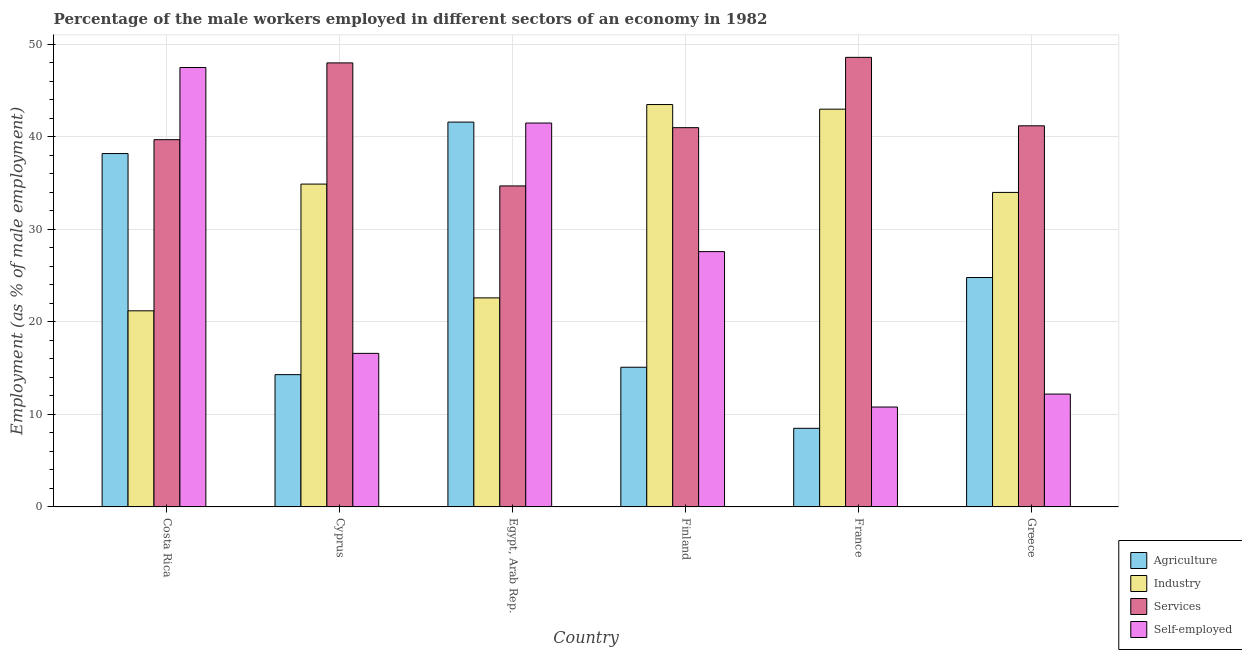How many different coloured bars are there?
Offer a terse response. 4. How many groups of bars are there?
Keep it short and to the point. 6. Are the number of bars per tick equal to the number of legend labels?
Make the answer very short. Yes. How many bars are there on the 2nd tick from the left?
Give a very brief answer. 4. What is the label of the 5th group of bars from the left?
Offer a very short reply. France. In how many cases, is the number of bars for a given country not equal to the number of legend labels?
Provide a short and direct response. 0. What is the percentage of male workers in services in France?
Offer a terse response. 48.6. Across all countries, what is the maximum percentage of male workers in agriculture?
Offer a very short reply. 41.6. Across all countries, what is the minimum percentage of male workers in services?
Your answer should be compact. 34.7. In which country was the percentage of male workers in services minimum?
Provide a short and direct response. Egypt, Arab Rep. What is the total percentage of male workers in agriculture in the graph?
Your response must be concise. 142.5. What is the difference between the percentage of self employed male workers in Greece and the percentage of male workers in services in France?
Make the answer very short. -36.4. What is the average percentage of male workers in services per country?
Make the answer very short. 42.2. What is the difference between the percentage of male workers in agriculture and percentage of male workers in industry in Egypt, Arab Rep.?
Ensure brevity in your answer.  19. In how many countries, is the percentage of self employed male workers greater than 48 %?
Ensure brevity in your answer.  0. What is the ratio of the percentage of male workers in services in Costa Rica to that in Egypt, Arab Rep.?
Make the answer very short. 1.14. Is the percentage of self employed male workers in France less than that in Greece?
Your answer should be compact. Yes. What is the difference between the highest and the lowest percentage of male workers in industry?
Offer a very short reply. 22.3. In how many countries, is the percentage of male workers in industry greater than the average percentage of male workers in industry taken over all countries?
Offer a terse response. 4. What does the 2nd bar from the left in Costa Rica represents?
Offer a terse response. Industry. What does the 4th bar from the right in Costa Rica represents?
Your answer should be very brief. Agriculture. Is it the case that in every country, the sum of the percentage of male workers in agriculture and percentage of male workers in industry is greater than the percentage of male workers in services?
Make the answer very short. Yes. How many countries are there in the graph?
Your response must be concise. 6. Does the graph contain grids?
Offer a very short reply. Yes. Where does the legend appear in the graph?
Ensure brevity in your answer.  Bottom right. How are the legend labels stacked?
Your answer should be very brief. Vertical. What is the title of the graph?
Give a very brief answer. Percentage of the male workers employed in different sectors of an economy in 1982. Does "Payroll services" appear as one of the legend labels in the graph?
Your answer should be compact. No. What is the label or title of the Y-axis?
Your answer should be very brief. Employment (as % of male employment). What is the Employment (as % of male employment) of Agriculture in Costa Rica?
Provide a short and direct response. 38.2. What is the Employment (as % of male employment) in Industry in Costa Rica?
Your answer should be compact. 21.2. What is the Employment (as % of male employment) in Services in Costa Rica?
Make the answer very short. 39.7. What is the Employment (as % of male employment) of Self-employed in Costa Rica?
Your answer should be compact. 47.5. What is the Employment (as % of male employment) of Agriculture in Cyprus?
Make the answer very short. 14.3. What is the Employment (as % of male employment) in Industry in Cyprus?
Offer a terse response. 34.9. What is the Employment (as % of male employment) of Services in Cyprus?
Ensure brevity in your answer.  48. What is the Employment (as % of male employment) of Self-employed in Cyprus?
Your answer should be compact. 16.6. What is the Employment (as % of male employment) in Agriculture in Egypt, Arab Rep.?
Ensure brevity in your answer.  41.6. What is the Employment (as % of male employment) in Industry in Egypt, Arab Rep.?
Offer a very short reply. 22.6. What is the Employment (as % of male employment) of Services in Egypt, Arab Rep.?
Give a very brief answer. 34.7. What is the Employment (as % of male employment) in Self-employed in Egypt, Arab Rep.?
Offer a terse response. 41.5. What is the Employment (as % of male employment) of Agriculture in Finland?
Give a very brief answer. 15.1. What is the Employment (as % of male employment) of Industry in Finland?
Give a very brief answer. 43.5. What is the Employment (as % of male employment) in Services in Finland?
Give a very brief answer. 41. What is the Employment (as % of male employment) in Self-employed in Finland?
Give a very brief answer. 27.6. What is the Employment (as % of male employment) in Agriculture in France?
Give a very brief answer. 8.5. What is the Employment (as % of male employment) in Services in France?
Your response must be concise. 48.6. What is the Employment (as % of male employment) of Self-employed in France?
Give a very brief answer. 10.8. What is the Employment (as % of male employment) in Agriculture in Greece?
Make the answer very short. 24.8. What is the Employment (as % of male employment) in Industry in Greece?
Offer a very short reply. 34. What is the Employment (as % of male employment) in Services in Greece?
Offer a terse response. 41.2. What is the Employment (as % of male employment) of Self-employed in Greece?
Your answer should be compact. 12.2. Across all countries, what is the maximum Employment (as % of male employment) of Agriculture?
Your answer should be very brief. 41.6. Across all countries, what is the maximum Employment (as % of male employment) of Industry?
Your response must be concise. 43.5. Across all countries, what is the maximum Employment (as % of male employment) of Services?
Your answer should be compact. 48.6. Across all countries, what is the maximum Employment (as % of male employment) in Self-employed?
Offer a terse response. 47.5. Across all countries, what is the minimum Employment (as % of male employment) in Industry?
Offer a terse response. 21.2. Across all countries, what is the minimum Employment (as % of male employment) of Services?
Your answer should be very brief. 34.7. Across all countries, what is the minimum Employment (as % of male employment) of Self-employed?
Your response must be concise. 10.8. What is the total Employment (as % of male employment) of Agriculture in the graph?
Make the answer very short. 142.5. What is the total Employment (as % of male employment) in Industry in the graph?
Your answer should be very brief. 199.2. What is the total Employment (as % of male employment) of Services in the graph?
Ensure brevity in your answer.  253.2. What is the total Employment (as % of male employment) in Self-employed in the graph?
Keep it short and to the point. 156.2. What is the difference between the Employment (as % of male employment) in Agriculture in Costa Rica and that in Cyprus?
Provide a short and direct response. 23.9. What is the difference between the Employment (as % of male employment) in Industry in Costa Rica and that in Cyprus?
Keep it short and to the point. -13.7. What is the difference between the Employment (as % of male employment) of Services in Costa Rica and that in Cyprus?
Your response must be concise. -8.3. What is the difference between the Employment (as % of male employment) in Self-employed in Costa Rica and that in Cyprus?
Provide a short and direct response. 30.9. What is the difference between the Employment (as % of male employment) in Services in Costa Rica and that in Egypt, Arab Rep.?
Your response must be concise. 5. What is the difference between the Employment (as % of male employment) in Self-employed in Costa Rica and that in Egypt, Arab Rep.?
Your response must be concise. 6. What is the difference between the Employment (as % of male employment) of Agriculture in Costa Rica and that in Finland?
Your answer should be compact. 23.1. What is the difference between the Employment (as % of male employment) of Industry in Costa Rica and that in Finland?
Offer a terse response. -22.3. What is the difference between the Employment (as % of male employment) of Agriculture in Costa Rica and that in France?
Your response must be concise. 29.7. What is the difference between the Employment (as % of male employment) in Industry in Costa Rica and that in France?
Give a very brief answer. -21.8. What is the difference between the Employment (as % of male employment) of Services in Costa Rica and that in France?
Ensure brevity in your answer.  -8.9. What is the difference between the Employment (as % of male employment) of Self-employed in Costa Rica and that in France?
Make the answer very short. 36.7. What is the difference between the Employment (as % of male employment) in Agriculture in Costa Rica and that in Greece?
Provide a succinct answer. 13.4. What is the difference between the Employment (as % of male employment) of Services in Costa Rica and that in Greece?
Provide a short and direct response. -1.5. What is the difference between the Employment (as % of male employment) of Self-employed in Costa Rica and that in Greece?
Offer a terse response. 35.3. What is the difference between the Employment (as % of male employment) in Agriculture in Cyprus and that in Egypt, Arab Rep.?
Provide a succinct answer. -27.3. What is the difference between the Employment (as % of male employment) of Industry in Cyprus and that in Egypt, Arab Rep.?
Ensure brevity in your answer.  12.3. What is the difference between the Employment (as % of male employment) of Self-employed in Cyprus and that in Egypt, Arab Rep.?
Your answer should be compact. -24.9. What is the difference between the Employment (as % of male employment) in Agriculture in Cyprus and that in Finland?
Your answer should be compact. -0.8. What is the difference between the Employment (as % of male employment) of Industry in Cyprus and that in Finland?
Your response must be concise. -8.6. What is the difference between the Employment (as % of male employment) of Services in Cyprus and that in Finland?
Keep it short and to the point. 7. What is the difference between the Employment (as % of male employment) of Agriculture in Cyprus and that in France?
Offer a terse response. 5.8. What is the difference between the Employment (as % of male employment) in Industry in Cyprus and that in France?
Offer a very short reply. -8.1. What is the difference between the Employment (as % of male employment) of Industry in Egypt, Arab Rep. and that in Finland?
Your answer should be very brief. -20.9. What is the difference between the Employment (as % of male employment) in Services in Egypt, Arab Rep. and that in Finland?
Make the answer very short. -6.3. What is the difference between the Employment (as % of male employment) in Self-employed in Egypt, Arab Rep. and that in Finland?
Your answer should be very brief. 13.9. What is the difference between the Employment (as % of male employment) of Agriculture in Egypt, Arab Rep. and that in France?
Your answer should be very brief. 33.1. What is the difference between the Employment (as % of male employment) of Industry in Egypt, Arab Rep. and that in France?
Your response must be concise. -20.4. What is the difference between the Employment (as % of male employment) in Services in Egypt, Arab Rep. and that in France?
Your response must be concise. -13.9. What is the difference between the Employment (as % of male employment) in Self-employed in Egypt, Arab Rep. and that in France?
Your answer should be compact. 30.7. What is the difference between the Employment (as % of male employment) in Agriculture in Egypt, Arab Rep. and that in Greece?
Provide a succinct answer. 16.8. What is the difference between the Employment (as % of male employment) of Industry in Egypt, Arab Rep. and that in Greece?
Ensure brevity in your answer.  -11.4. What is the difference between the Employment (as % of male employment) of Services in Egypt, Arab Rep. and that in Greece?
Your response must be concise. -6.5. What is the difference between the Employment (as % of male employment) of Self-employed in Egypt, Arab Rep. and that in Greece?
Your response must be concise. 29.3. What is the difference between the Employment (as % of male employment) of Agriculture in Finland and that in France?
Offer a terse response. 6.6. What is the difference between the Employment (as % of male employment) of Services in Finland and that in France?
Offer a very short reply. -7.6. What is the difference between the Employment (as % of male employment) in Self-employed in Finland and that in France?
Offer a very short reply. 16.8. What is the difference between the Employment (as % of male employment) in Services in Finland and that in Greece?
Keep it short and to the point. -0.2. What is the difference between the Employment (as % of male employment) of Agriculture in France and that in Greece?
Give a very brief answer. -16.3. What is the difference between the Employment (as % of male employment) of Services in France and that in Greece?
Offer a terse response. 7.4. What is the difference between the Employment (as % of male employment) of Self-employed in France and that in Greece?
Ensure brevity in your answer.  -1.4. What is the difference between the Employment (as % of male employment) of Agriculture in Costa Rica and the Employment (as % of male employment) of Self-employed in Cyprus?
Your answer should be compact. 21.6. What is the difference between the Employment (as % of male employment) of Industry in Costa Rica and the Employment (as % of male employment) of Services in Cyprus?
Provide a short and direct response. -26.8. What is the difference between the Employment (as % of male employment) of Industry in Costa Rica and the Employment (as % of male employment) of Self-employed in Cyprus?
Provide a succinct answer. 4.6. What is the difference between the Employment (as % of male employment) of Services in Costa Rica and the Employment (as % of male employment) of Self-employed in Cyprus?
Provide a short and direct response. 23.1. What is the difference between the Employment (as % of male employment) in Agriculture in Costa Rica and the Employment (as % of male employment) in Industry in Egypt, Arab Rep.?
Your response must be concise. 15.6. What is the difference between the Employment (as % of male employment) of Agriculture in Costa Rica and the Employment (as % of male employment) of Services in Egypt, Arab Rep.?
Make the answer very short. 3.5. What is the difference between the Employment (as % of male employment) of Industry in Costa Rica and the Employment (as % of male employment) of Services in Egypt, Arab Rep.?
Provide a short and direct response. -13.5. What is the difference between the Employment (as % of male employment) in Industry in Costa Rica and the Employment (as % of male employment) in Self-employed in Egypt, Arab Rep.?
Your response must be concise. -20.3. What is the difference between the Employment (as % of male employment) in Services in Costa Rica and the Employment (as % of male employment) in Self-employed in Egypt, Arab Rep.?
Offer a very short reply. -1.8. What is the difference between the Employment (as % of male employment) in Agriculture in Costa Rica and the Employment (as % of male employment) in Self-employed in Finland?
Offer a terse response. 10.6. What is the difference between the Employment (as % of male employment) of Industry in Costa Rica and the Employment (as % of male employment) of Services in Finland?
Give a very brief answer. -19.8. What is the difference between the Employment (as % of male employment) in Industry in Costa Rica and the Employment (as % of male employment) in Self-employed in Finland?
Your answer should be compact. -6.4. What is the difference between the Employment (as % of male employment) of Services in Costa Rica and the Employment (as % of male employment) of Self-employed in Finland?
Your response must be concise. 12.1. What is the difference between the Employment (as % of male employment) in Agriculture in Costa Rica and the Employment (as % of male employment) in Industry in France?
Make the answer very short. -4.8. What is the difference between the Employment (as % of male employment) in Agriculture in Costa Rica and the Employment (as % of male employment) in Self-employed in France?
Provide a succinct answer. 27.4. What is the difference between the Employment (as % of male employment) of Industry in Costa Rica and the Employment (as % of male employment) of Services in France?
Provide a succinct answer. -27.4. What is the difference between the Employment (as % of male employment) of Industry in Costa Rica and the Employment (as % of male employment) of Self-employed in France?
Offer a terse response. 10.4. What is the difference between the Employment (as % of male employment) in Services in Costa Rica and the Employment (as % of male employment) in Self-employed in France?
Ensure brevity in your answer.  28.9. What is the difference between the Employment (as % of male employment) of Agriculture in Costa Rica and the Employment (as % of male employment) of Industry in Greece?
Provide a succinct answer. 4.2. What is the difference between the Employment (as % of male employment) in Agriculture in Costa Rica and the Employment (as % of male employment) in Self-employed in Greece?
Keep it short and to the point. 26. What is the difference between the Employment (as % of male employment) in Industry in Costa Rica and the Employment (as % of male employment) in Services in Greece?
Offer a terse response. -20. What is the difference between the Employment (as % of male employment) in Agriculture in Cyprus and the Employment (as % of male employment) in Services in Egypt, Arab Rep.?
Offer a terse response. -20.4. What is the difference between the Employment (as % of male employment) in Agriculture in Cyprus and the Employment (as % of male employment) in Self-employed in Egypt, Arab Rep.?
Ensure brevity in your answer.  -27.2. What is the difference between the Employment (as % of male employment) of Industry in Cyprus and the Employment (as % of male employment) of Services in Egypt, Arab Rep.?
Offer a terse response. 0.2. What is the difference between the Employment (as % of male employment) in Industry in Cyprus and the Employment (as % of male employment) in Self-employed in Egypt, Arab Rep.?
Provide a short and direct response. -6.6. What is the difference between the Employment (as % of male employment) in Services in Cyprus and the Employment (as % of male employment) in Self-employed in Egypt, Arab Rep.?
Provide a succinct answer. 6.5. What is the difference between the Employment (as % of male employment) of Agriculture in Cyprus and the Employment (as % of male employment) of Industry in Finland?
Offer a very short reply. -29.2. What is the difference between the Employment (as % of male employment) in Agriculture in Cyprus and the Employment (as % of male employment) in Services in Finland?
Ensure brevity in your answer.  -26.7. What is the difference between the Employment (as % of male employment) in Services in Cyprus and the Employment (as % of male employment) in Self-employed in Finland?
Your answer should be very brief. 20.4. What is the difference between the Employment (as % of male employment) of Agriculture in Cyprus and the Employment (as % of male employment) of Industry in France?
Make the answer very short. -28.7. What is the difference between the Employment (as % of male employment) of Agriculture in Cyprus and the Employment (as % of male employment) of Services in France?
Provide a short and direct response. -34.3. What is the difference between the Employment (as % of male employment) in Agriculture in Cyprus and the Employment (as % of male employment) in Self-employed in France?
Offer a very short reply. 3.5. What is the difference between the Employment (as % of male employment) of Industry in Cyprus and the Employment (as % of male employment) of Services in France?
Your response must be concise. -13.7. What is the difference between the Employment (as % of male employment) of Industry in Cyprus and the Employment (as % of male employment) of Self-employed in France?
Keep it short and to the point. 24.1. What is the difference between the Employment (as % of male employment) of Services in Cyprus and the Employment (as % of male employment) of Self-employed in France?
Keep it short and to the point. 37.2. What is the difference between the Employment (as % of male employment) of Agriculture in Cyprus and the Employment (as % of male employment) of Industry in Greece?
Provide a short and direct response. -19.7. What is the difference between the Employment (as % of male employment) in Agriculture in Cyprus and the Employment (as % of male employment) in Services in Greece?
Provide a succinct answer. -26.9. What is the difference between the Employment (as % of male employment) of Industry in Cyprus and the Employment (as % of male employment) of Self-employed in Greece?
Provide a succinct answer. 22.7. What is the difference between the Employment (as % of male employment) in Services in Cyprus and the Employment (as % of male employment) in Self-employed in Greece?
Make the answer very short. 35.8. What is the difference between the Employment (as % of male employment) of Agriculture in Egypt, Arab Rep. and the Employment (as % of male employment) of Services in Finland?
Provide a succinct answer. 0.6. What is the difference between the Employment (as % of male employment) of Agriculture in Egypt, Arab Rep. and the Employment (as % of male employment) of Self-employed in Finland?
Keep it short and to the point. 14. What is the difference between the Employment (as % of male employment) in Industry in Egypt, Arab Rep. and the Employment (as % of male employment) in Services in Finland?
Your response must be concise. -18.4. What is the difference between the Employment (as % of male employment) of Agriculture in Egypt, Arab Rep. and the Employment (as % of male employment) of Services in France?
Provide a short and direct response. -7. What is the difference between the Employment (as % of male employment) in Agriculture in Egypt, Arab Rep. and the Employment (as % of male employment) in Self-employed in France?
Your response must be concise. 30.8. What is the difference between the Employment (as % of male employment) in Services in Egypt, Arab Rep. and the Employment (as % of male employment) in Self-employed in France?
Your response must be concise. 23.9. What is the difference between the Employment (as % of male employment) of Agriculture in Egypt, Arab Rep. and the Employment (as % of male employment) of Services in Greece?
Your answer should be very brief. 0.4. What is the difference between the Employment (as % of male employment) in Agriculture in Egypt, Arab Rep. and the Employment (as % of male employment) in Self-employed in Greece?
Ensure brevity in your answer.  29.4. What is the difference between the Employment (as % of male employment) of Industry in Egypt, Arab Rep. and the Employment (as % of male employment) of Services in Greece?
Make the answer very short. -18.6. What is the difference between the Employment (as % of male employment) in Industry in Egypt, Arab Rep. and the Employment (as % of male employment) in Self-employed in Greece?
Your response must be concise. 10.4. What is the difference between the Employment (as % of male employment) of Agriculture in Finland and the Employment (as % of male employment) of Industry in France?
Give a very brief answer. -27.9. What is the difference between the Employment (as % of male employment) of Agriculture in Finland and the Employment (as % of male employment) of Services in France?
Your answer should be compact. -33.5. What is the difference between the Employment (as % of male employment) of Industry in Finland and the Employment (as % of male employment) of Self-employed in France?
Keep it short and to the point. 32.7. What is the difference between the Employment (as % of male employment) in Services in Finland and the Employment (as % of male employment) in Self-employed in France?
Your answer should be very brief. 30.2. What is the difference between the Employment (as % of male employment) in Agriculture in Finland and the Employment (as % of male employment) in Industry in Greece?
Ensure brevity in your answer.  -18.9. What is the difference between the Employment (as % of male employment) in Agriculture in Finland and the Employment (as % of male employment) in Services in Greece?
Provide a short and direct response. -26.1. What is the difference between the Employment (as % of male employment) in Industry in Finland and the Employment (as % of male employment) in Self-employed in Greece?
Your response must be concise. 31.3. What is the difference between the Employment (as % of male employment) of Services in Finland and the Employment (as % of male employment) of Self-employed in Greece?
Your answer should be very brief. 28.8. What is the difference between the Employment (as % of male employment) in Agriculture in France and the Employment (as % of male employment) in Industry in Greece?
Your answer should be very brief. -25.5. What is the difference between the Employment (as % of male employment) of Agriculture in France and the Employment (as % of male employment) of Services in Greece?
Your answer should be compact. -32.7. What is the difference between the Employment (as % of male employment) in Agriculture in France and the Employment (as % of male employment) in Self-employed in Greece?
Provide a short and direct response. -3.7. What is the difference between the Employment (as % of male employment) in Industry in France and the Employment (as % of male employment) in Self-employed in Greece?
Offer a very short reply. 30.8. What is the difference between the Employment (as % of male employment) of Services in France and the Employment (as % of male employment) of Self-employed in Greece?
Your answer should be very brief. 36.4. What is the average Employment (as % of male employment) of Agriculture per country?
Provide a short and direct response. 23.75. What is the average Employment (as % of male employment) of Industry per country?
Give a very brief answer. 33.2. What is the average Employment (as % of male employment) in Services per country?
Your response must be concise. 42.2. What is the average Employment (as % of male employment) of Self-employed per country?
Provide a succinct answer. 26.03. What is the difference between the Employment (as % of male employment) of Agriculture and Employment (as % of male employment) of Industry in Costa Rica?
Ensure brevity in your answer.  17. What is the difference between the Employment (as % of male employment) of Industry and Employment (as % of male employment) of Services in Costa Rica?
Your answer should be compact. -18.5. What is the difference between the Employment (as % of male employment) of Industry and Employment (as % of male employment) of Self-employed in Costa Rica?
Provide a succinct answer. -26.3. What is the difference between the Employment (as % of male employment) of Agriculture and Employment (as % of male employment) of Industry in Cyprus?
Provide a succinct answer. -20.6. What is the difference between the Employment (as % of male employment) of Agriculture and Employment (as % of male employment) of Services in Cyprus?
Make the answer very short. -33.7. What is the difference between the Employment (as % of male employment) in Services and Employment (as % of male employment) in Self-employed in Cyprus?
Provide a short and direct response. 31.4. What is the difference between the Employment (as % of male employment) in Agriculture and Employment (as % of male employment) in Industry in Egypt, Arab Rep.?
Ensure brevity in your answer.  19. What is the difference between the Employment (as % of male employment) in Agriculture and Employment (as % of male employment) in Services in Egypt, Arab Rep.?
Make the answer very short. 6.9. What is the difference between the Employment (as % of male employment) of Industry and Employment (as % of male employment) of Self-employed in Egypt, Arab Rep.?
Provide a short and direct response. -18.9. What is the difference between the Employment (as % of male employment) of Agriculture and Employment (as % of male employment) of Industry in Finland?
Provide a short and direct response. -28.4. What is the difference between the Employment (as % of male employment) of Agriculture and Employment (as % of male employment) of Services in Finland?
Give a very brief answer. -25.9. What is the difference between the Employment (as % of male employment) in Industry and Employment (as % of male employment) in Self-employed in Finland?
Ensure brevity in your answer.  15.9. What is the difference between the Employment (as % of male employment) in Services and Employment (as % of male employment) in Self-employed in Finland?
Give a very brief answer. 13.4. What is the difference between the Employment (as % of male employment) of Agriculture and Employment (as % of male employment) of Industry in France?
Offer a terse response. -34.5. What is the difference between the Employment (as % of male employment) in Agriculture and Employment (as % of male employment) in Services in France?
Your response must be concise. -40.1. What is the difference between the Employment (as % of male employment) in Agriculture and Employment (as % of male employment) in Self-employed in France?
Provide a short and direct response. -2.3. What is the difference between the Employment (as % of male employment) in Industry and Employment (as % of male employment) in Self-employed in France?
Your response must be concise. 32.2. What is the difference between the Employment (as % of male employment) in Services and Employment (as % of male employment) in Self-employed in France?
Provide a short and direct response. 37.8. What is the difference between the Employment (as % of male employment) in Agriculture and Employment (as % of male employment) in Industry in Greece?
Make the answer very short. -9.2. What is the difference between the Employment (as % of male employment) in Agriculture and Employment (as % of male employment) in Services in Greece?
Your answer should be very brief. -16.4. What is the difference between the Employment (as % of male employment) of Agriculture and Employment (as % of male employment) of Self-employed in Greece?
Your response must be concise. 12.6. What is the difference between the Employment (as % of male employment) in Industry and Employment (as % of male employment) in Self-employed in Greece?
Provide a succinct answer. 21.8. What is the ratio of the Employment (as % of male employment) in Agriculture in Costa Rica to that in Cyprus?
Your response must be concise. 2.67. What is the ratio of the Employment (as % of male employment) in Industry in Costa Rica to that in Cyprus?
Your answer should be very brief. 0.61. What is the ratio of the Employment (as % of male employment) of Services in Costa Rica to that in Cyprus?
Your answer should be very brief. 0.83. What is the ratio of the Employment (as % of male employment) of Self-employed in Costa Rica to that in Cyprus?
Ensure brevity in your answer.  2.86. What is the ratio of the Employment (as % of male employment) of Agriculture in Costa Rica to that in Egypt, Arab Rep.?
Ensure brevity in your answer.  0.92. What is the ratio of the Employment (as % of male employment) of Industry in Costa Rica to that in Egypt, Arab Rep.?
Your response must be concise. 0.94. What is the ratio of the Employment (as % of male employment) of Services in Costa Rica to that in Egypt, Arab Rep.?
Give a very brief answer. 1.14. What is the ratio of the Employment (as % of male employment) of Self-employed in Costa Rica to that in Egypt, Arab Rep.?
Offer a terse response. 1.14. What is the ratio of the Employment (as % of male employment) in Agriculture in Costa Rica to that in Finland?
Give a very brief answer. 2.53. What is the ratio of the Employment (as % of male employment) in Industry in Costa Rica to that in Finland?
Make the answer very short. 0.49. What is the ratio of the Employment (as % of male employment) of Services in Costa Rica to that in Finland?
Offer a terse response. 0.97. What is the ratio of the Employment (as % of male employment) in Self-employed in Costa Rica to that in Finland?
Offer a terse response. 1.72. What is the ratio of the Employment (as % of male employment) in Agriculture in Costa Rica to that in France?
Keep it short and to the point. 4.49. What is the ratio of the Employment (as % of male employment) in Industry in Costa Rica to that in France?
Your answer should be compact. 0.49. What is the ratio of the Employment (as % of male employment) of Services in Costa Rica to that in France?
Provide a short and direct response. 0.82. What is the ratio of the Employment (as % of male employment) in Self-employed in Costa Rica to that in France?
Your response must be concise. 4.4. What is the ratio of the Employment (as % of male employment) in Agriculture in Costa Rica to that in Greece?
Your answer should be compact. 1.54. What is the ratio of the Employment (as % of male employment) in Industry in Costa Rica to that in Greece?
Your response must be concise. 0.62. What is the ratio of the Employment (as % of male employment) of Services in Costa Rica to that in Greece?
Offer a very short reply. 0.96. What is the ratio of the Employment (as % of male employment) of Self-employed in Costa Rica to that in Greece?
Your answer should be very brief. 3.89. What is the ratio of the Employment (as % of male employment) in Agriculture in Cyprus to that in Egypt, Arab Rep.?
Offer a terse response. 0.34. What is the ratio of the Employment (as % of male employment) of Industry in Cyprus to that in Egypt, Arab Rep.?
Provide a short and direct response. 1.54. What is the ratio of the Employment (as % of male employment) of Services in Cyprus to that in Egypt, Arab Rep.?
Give a very brief answer. 1.38. What is the ratio of the Employment (as % of male employment) in Self-employed in Cyprus to that in Egypt, Arab Rep.?
Provide a short and direct response. 0.4. What is the ratio of the Employment (as % of male employment) of Agriculture in Cyprus to that in Finland?
Ensure brevity in your answer.  0.95. What is the ratio of the Employment (as % of male employment) of Industry in Cyprus to that in Finland?
Your answer should be compact. 0.8. What is the ratio of the Employment (as % of male employment) in Services in Cyprus to that in Finland?
Keep it short and to the point. 1.17. What is the ratio of the Employment (as % of male employment) in Self-employed in Cyprus to that in Finland?
Give a very brief answer. 0.6. What is the ratio of the Employment (as % of male employment) in Agriculture in Cyprus to that in France?
Ensure brevity in your answer.  1.68. What is the ratio of the Employment (as % of male employment) in Industry in Cyprus to that in France?
Your answer should be compact. 0.81. What is the ratio of the Employment (as % of male employment) in Services in Cyprus to that in France?
Ensure brevity in your answer.  0.99. What is the ratio of the Employment (as % of male employment) of Self-employed in Cyprus to that in France?
Provide a short and direct response. 1.54. What is the ratio of the Employment (as % of male employment) of Agriculture in Cyprus to that in Greece?
Your response must be concise. 0.58. What is the ratio of the Employment (as % of male employment) in Industry in Cyprus to that in Greece?
Ensure brevity in your answer.  1.03. What is the ratio of the Employment (as % of male employment) in Services in Cyprus to that in Greece?
Provide a succinct answer. 1.17. What is the ratio of the Employment (as % of male employment) in Self-employed in Cyprus to that in Greece?
Give a very brief answer. 1.36. What is the ratio of the Employment (as % of male employment) of Agriculture in Egypt, Arab Rep. to that in Finland?
Make the answer very short. 2.75. What is the ratio of the Employment (as % of male employment) in Industry in Egypt, Arab Rep. to that in Finland?
Provide a succinct answer. 0.52. What is the ratio of the Employment (as % of male employment) of Services in Egypt, Arab Rep. to that in Finland?
Offer a very short reply. 0.85. What is the ratio of the Employment (as % of male employment) in Self-employed in Egypt, Arab Rep. to that in Finland?
Make the answer very short. 1.5. What is the ratio of the Employment (as % of male employment) of Agriculture in Egypt, Arab Rep. to that in France?
Your response must be concise. 4.89. What is the ratio of the Employment (as % of male employment) in Industry in Egypt, Arab Rep. to that in France?
Provide a short and direct response. 0.53. What is the ratio of the Employment (as % of male employment) in Services in Egypt, Arab Rep. to that in France?
Your answer should be very brief. 0.71. What is the ratio of the Employment (as % of male employment) in Self-employed in Egypt, Arab Rep. to that in France?
Ensure brevity in your answer.  3.84. What is the ratio of the Employment (as % of male employment) of Agriculture in Egypt, Arab Rep. to that in Greece?
Ensure brevity in your answer.  1.68. What is the ratio of the Employment (as % of male employment) in Industry in Egypt, Arab Rep. to that in Greece?
Your answer should be compact. 0.66. What is the ratio of the Employment (as % of male employment) in Services in Egypt, Arab Rep. to that in Greece?
Your answer should be very brief. 0.84. What is the ratio of the Employment (as % of male employment) in Self-employed in Egypt, Arab Rep. to that in Greece?
Provide a succinct answer. 3.4. What is the ratio of the Employment (as % of male employment) of Agriculture in Finland to that in France?
Your answer should be compact. 1.78. What is the ratio of the Employment (as % of male employment) of Industry in Finland to that in France?
Give a very brief answer. 1.01. What is the ratio of the Employment (as % of male employment) in Services in Finland to that in France?
Your answer should be compact. 0.84. What is the ratio of the Employment (as % of male employment) of Self-employed in Finland to that in France?
Give a very brief answer. 2.56. What is the ratio of the Employment (as % of male employment) of Agriculture in Finland to that in Greece?
Your answer should be compact. 0.61. What is the ratio of the Employment (as % of male employment) in Industry in Finland to that in Greece?
Provide a short and direct response. 1.28. What is the ratio of the Employment (as % of male employment) of Services in Finland to that in Greece?
Ensure brevity in your answer.  1. What is the ratio of the Employment (as % of male employment) of Self-employed in Finland to that in Greece?
Provide a succinct answer. 2.26. What is the ratio of the Employment (as % of male employment) of Agriculture in France to that in Greece?
Make the answer very short. 0.34. What is the ratio of the Employment (as % of male employment) of Industry in France to that in Greece?
Your answer should be compact. 1.26. What is the ratio of the Employment (as % of male employment) in Services in France to that in Greece?
Provide a succinct answer. 1.18. What is the ratio of the Employment (as % of male employment) in Self-employed in France to that in Greece?
Make the answer very short. 0.89. What is the difference between the highest and the second highest Employment (as % of male employment) of Agriculture?
Offer a terse response. 3.4. What is the difference between the highest and the lowest Employment (as % of male employment) in Agriculture?
Your answer should be very brief. 33.1. What is the difference between the highest and the lowest Employment (as % of male employment) in Industry?
Provide a short and direct response. 22.3. What is the difference between the highest and the lowest Employment (as % of male employment) of Services?
Your response must be concise. 13.9. What is the difference between the highest and the lowest Employment (as % of male employment) in Self-employed?
Your response must be concise. 36.7. 